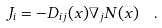Convert formula to latex. <formula><loc_0><loc_0><loc_500><loc_500>J _ { i } = - D _ { i j } ( x ) \nabla _ { j } N ( x ) \ \ .</formula> 